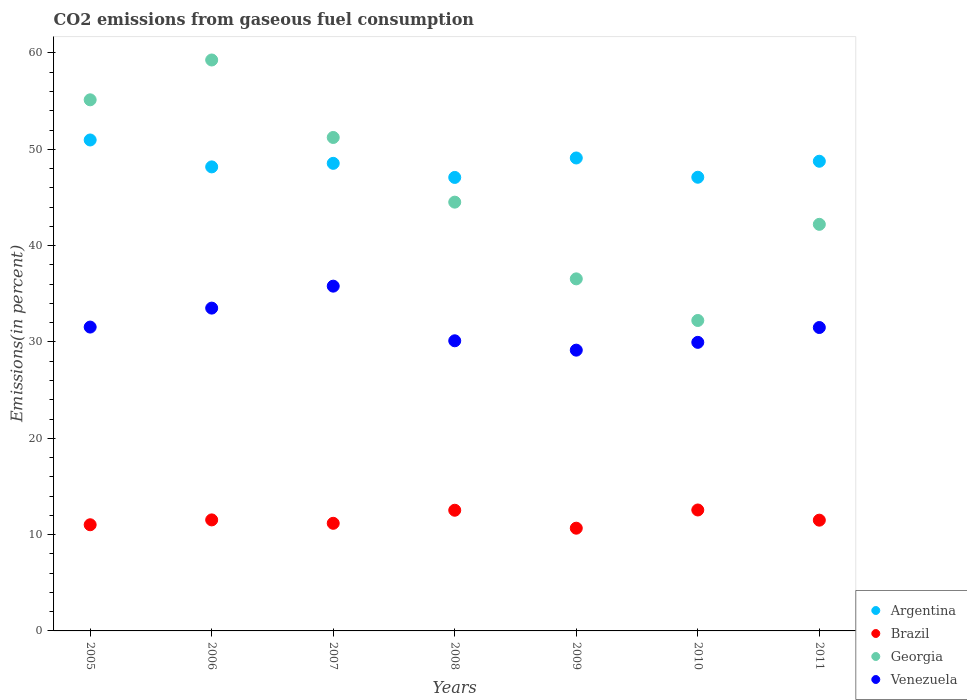What is the total CO2 emitted in Venezuela in 2011?
Your answer should be compact. 31.5. Across all years, what is the maximum total CO2 emitted in Venezuela?
Your answer should be compact. 35.79. Across all years, what is the minimum total CO2 emitted in Georgia?
Offer a terse response. 32.23. In which year was the total CO2 emitted in Argentina maximum?
Ensure brevity in your answer.  2005. What is the total total CO2 emitted in Venezuela in the graph?
Your answer should be compact. 221.58. What is the difference between the total CO2 emitted in Argentina in 2008 and that in 2010?
Your answer should be very brief. -0.02. What is the difference between the total CO2 emitted in Venezuela in 2011 and the total CO2 emitted in Argentina in 2007?
Provide a succinct answer. -17.04. What is the average total CO2 emitted in Georgia per year?
Offer a terse response. 45.88. In the year 2010, what is the difference between the total CO2 emitted in Argentina and total CO2 emitted in Venezuela?
Give a very brief answer. 17.14. What is the ratio of the total CO2 emitted in Venezuela in 2007 to that in 2009?
Your answer should be compact. 1.23. What is the difference between the highest and the second highest total CO2 emitted in Georgia?
Provide a succinct answer. 4.14. What is the difference between the highest and the lowest total CO2 emitted in Venezuela?
Your response must be concise. 6.64. Is the sum of the total CO2 emitted in Argentina in 2005 and 2008 greater than the maximum total CO2 emitted in Venezuela across all years?
Give a very brief answer. Yes. Is it the case that in every year, the sum of the total CO2 emitted in Venezuela and total CO2 emitted in Argentina  is greater than the sum of total CO2 emitted in Georgia and total CO2 emitted in Brazil?
Your answer should be compact. Yes. Is it the case that in every year, the sum of the total CO2 emitted in Georgia and total CO2 emitted in Argentina  is greater than the total CO2 emitted in Venezuela?
Give a very brief answer. Yes. Is the total CO2 emitted in Argentina strictly greater than the total CO2 emitted in Georgia over the years?
Keep it short and to the point. No. Is the total CO2 emitted in Venezuela strictly less than the total CO2 emitted in Brazil over the years?
Make the answer very short. No. How many dotlines are there?
Your answer should be very brief. 4. How many years are there in the graph?
Your answer should be compact. 7. Are the values on the major ticks of Y-axis written in scientific E-notation?
Offer a terse response. No. Where does the legend appear in the graph?
Provide a succinct answer. Bottom right. How many legend labels are there?
Your answer should be compact. 4. What is the title of the graph?
Offer a very short reply. CO2 emissions from gaseous fuel consumption. What is the label or title of the Y-axis?
Ensure brevity in your answer.  Emissions(in percent). What is the Emissions(in percent) of Argentina in 2005?
Give a very brief answer. 50.97. What is the Emissions(in percent) in Brazil in 2005?
Provide a short and direct response. 11.02. What is the Emissions(in percent) in Georgia in 2005?
Keep it short and to the point. 55.14. What is the Emissions(in percent) in Venezuela in 2005?
Your answer should be very brief. 31.54. What is the Emissions(in percent) in Argentina in 2006?
Offer a terse response. 48.17. What is the Emissions(in percent) of Brazil in 2006?
Offer a very short reply. 11.53. What is the Emissions(in percent) in Georgia in 2006?
Your answer should be very brief. 59.27. What is the Emissions(in percent) of Venezuela in 2006?
Offer a terse response. 33.51. What is the Emissions(in percent) of Argentina in 2007?
Make the answer very short. 48.54. What is the Emissions(in percent) in Brazil in 2007?
Provide a succinct answer. 11.17. What is the Emissions(in percent) of Georgia in 2007?
Your answer should be very brief. 51.23. What is the Emissions(in percent) of Venezuela in 2007?
Offer a terse response. 35.79. What is the Emissions(in percent) of Argentina in 2008?
Give a very brief answer. 47.08. What is the Emissions(in percent) in Brazil in 2008?
Your answer should be compact. 12.53. What is the Emissions(in percent) in Georgia in 2008?
Make the answer very short. 44.51. What is the Emissions(in percent) of Venezuela in 2008?
Your response must be concise. 30.12. What is the Emissions(in percent) in Argentina in 2009?
Your answer should be very brief. 49.1. What is the Emissions(in percent) in Brazil in 2009?
Your answer should be very brief. 10.66. What is the Emissions(in percent) of Georgia in 2009?
Give a very brief answer. 36.55. What is the Emissions(in percent) of Venezuela in 2009?
Your answer should be very brief. 29.15. What is the Emissions(in percent) in Argentina in 2010?
Make the answer very short. 47.1. What is the Emissions(in percent) in Brazil in 2010?
Provide a succinct answer. 12.56. What is the Emissions(in percent) of Georgia in 2010?
Offer a terse response. 32.23. What is the Emissions(in percent) of Venezuela in 2010?
Make the answer very short. 29.96. What is the Emissions(in percent) of Argentina in 2011?
Offer a terse response. 48.76. What is the Emissions(in percent) of Brazil in 2011?
Your answer should be very brief. 11.5. What is the Emissions(in percent) of Georgia in 2011?
Your response must be concise. 42.21. What is the Emissions(in percent) in Venezuela in 2011?
Ensure brevity in your answer.  31.5. Across all years, what is the maximum Emissions(in percent) of Argentina?
Your answer should be compact. 50.97. Across all years, what is the maximum Emissions(in percent) of Brazil?
Your answer should be very brief. 12.56. Across all years, what is the maximum Emissions(in percent) in Georgia?
Your answer should be very brief. 59.27. Across all years, what is the maximum Emissions(in percent) in Venezuela?
Your answer should be very brief. 35.79. Across all years, what is the minimum Emissions(in percent) of Argentina?
Your answer should be very brief. 47.08. Across all years, what is the minimum Emissions(in percent) in Brazil?
Provide a short and direct response. 10.66. Across all years, what is the minimum Emissions(in percent) of Georgia?
Make the answer very short. 32.23. Across all years, what is the minimum Emissions(in percent) of Venezuela?
Your answer should be compact. 29.15. What is the total Emissions(in percent) of Argentina in the graph?
Your response must be concise. 339.72. What is the total Emissions(in percent) in Brazil in the graph?
Your answer should be compact. 80.97. What is the total Emissions(in percent) of Georgia in the graph?
Offer a very short reply. 321.14. What is the total Emissions(in percent) in Venezuela in the graph?
Your answer should be very brief. 221.58. What is the difference between the Emissions(in percent) of Argentina in 2005 and that in 2006?
Give a very brief answer. 2.79. What is the difference between the Emissions(in percent) in Brazil in 2005 and that in 2006?
Give a very brief answer. -0.5. What is the difference between the Emissions(in percent) in Georgia in 2005 and that in 2006?
Provide a short and direct response. -4.13. What is the difference between the Emissions(in percent) in Venezuela in 2005 and that in 2006?
Your answer should be very brief. -1.97. What is the difference between the Emissions(in percent) of Argentina in 2005 and that in 2007?
Make the answer very short. 2.43. What is the difference between the Emissions(in percent) of Brazil in 2005 and that in 2007?
Your response must be concise. -0.15. What is the difference between the Emissions(in percent) in Georgia in 2005 and that in 2007?
Provide a short and direct response. 3.91. What is the difference between the Emissions(in percent) in Venezuela in 2005 and that in 2007?
Keep it short and to the point. -4.25. What is the difference between the Emissions(in percent) in Argentina in 2005 and that in 2008?
Your response must be concise. 3.89. What is the difference between the Emissions(in percent) in Brazil in 2005 and that in 2008?
Your response must be concise. -1.51. What is the difference between the Emissions(in percent) in Georgia in 2005 and that in 2008?
Keep it short and to the point. 10.62. What is the difference between the Emissions(in percent) in Venezuela in 2005 and that in 2008?
Make the answer very short. 1.42. What is the difference between the Emissions(in percent) of Argentina in 2005 and that in 2009?
Keep it short and to the point. 1.87. What is the difference between the Emissions(in percent) of Brazil in 2005 and that in 2009?
Your answer should be very brief. 0.36. What is the difference between the Emissions(in percent) in Georgia in 2005 and that in 2009?
Your answer should be very brief. 18.59. What is the difference between the Emissions(in percent) of Venezuela in 2005 and that in 2009?
Provide a succinct answer. 2.4. What is the difference between the Emissions(in percent) of Argentina in 2005 and that in 2010?
Provide a succinct answer. 3.87. What is the difference between the Emissions(in percent) of Brazil in 2005 and that in 2010?
Offer a very short reply. -1.53. What is the difference between the Emissions(in percent) in Georgia in 2005 and that in 2010?
Provide a succinct answer. 22.91. What is the difference between the Emissions(in percent) of Venezuela in 2005 and that in 2010?
Give a very brief answer. 1.59. What is the difference between the Emissions(in percent) of Argentina in 2005 and that in 2011?
Keep it short and to the point. 2.21. What is the difference between the Emissions(in percent) in Brazil in 2005 and that in 2011?
Give a very brief answer. -0.48. What is the difference between the Emissions(in percent) in Georgia in 2005 and that in 2011?
Your answer should be very brief. 12.93. What is the difference between the Emissions(in percent) of Venezuela in 2005 and that in 2011?
Ensure brevity in your answer.  0.05. What is the difference between the Emissions(in percent) of Argentina in 2006 and that in 2007?
Provide a short and direct response. -0.37. What is the difference between the Emissions(in percent) in Brazil in 2006 and that in 2007?
Provide a short and direct response. 0.35. What is the difference between the Emissions(in percent) in Georgia in 2006 and that in 2007?
Keep it short and to the point. 8.04. What is the difference between the Emissions(in percent) of Venezuela in 2006 and that in 2007?
Your answer should be compact. -2.28. What is the difference between the Emissions(in percent) in Argentina in 2006 and that in 2008?
Provide a short and direct response. 1.1. What is the difference between the Emissions(in percent) of Brazil in 2006 and that in 2008?
Offer a very short reply. -1. What is the difference between the Emissions(in percent) of Georgia in 2006 and that in 2008?
Provide a succinct answer. 14.76. What is the difference between the Emissions(in percent) of Venezuela in 2006 and that in 2008?
Provide a succinct answer. 3.39. What is the difference between the Emissions(in percent) in Argentina in 2006 and that in 2009?
Keep it short and to the point. -0.93. What is the difference between the Emissions(in percent) in Brazil in 2006 and that in 2009?
Offer a terse response. 0.86. What is the difference between the Emissions(in percent) in Georgia in 2006 and that in 2009?
Provide a short and direct response. 22.72. What is the difference between the Emissions(in percent) of Venezuela in 2006 and that in 2009?
Keep it short and to the point. 4.36. What is the difference between the Emissions(in percent) in Argentina in 2006 and that in 2010?
Offer a terse response. 1.08. What is the difference between the Emissions(in percent) in Brazil in 2006 and that in 2010?
Make the answer very short. -1.03. What is the difference between the Emissions(in percent) in Georgia in 2006 and that in 2010?
Offer a terse response. 27.04. What is the difference between the Emissions(in percent) in Venezuela in 2006 and that in 2010?
Provide a short and direct response. 3.55. What is the difference between the Emissions(in percent) of Argentina in 2006 and that in 2011?
Keep it short and to the point. -0.59. What is the difference between the Emissions(in percent) of Brazil in 2006 and that in 2011?
Offer a terse response. 0.03. What is the difference between the Emissions(in percent) of Georgia in 2006 and that in 2011?
Your answer should be very brief. 17.06. What is the difference between the Emissions(in percent) in Venezuela in 2006 and that in 2011?
Your response must be concise. 2.01. What is the difference between the Emissions(in percent) in Argentina in 2007 and that in 2008?
Provide a short and direct response. 1.46. What is the difference between the Emissions(in percent) of Brazil in 2007 and that in 2008?
Ensure brevity in your answer.  -1.36. What is the difference between the Emissions(in percent) of Georgia in 2007 and that in 2008?
Provide a short and direct response. 6.71. What is the difference between the Emissions(in percent) of Venezuela in 2007 and that in 2008?
Provide a short and direct response. 5.67. What is the difference between the Emissions(in percent) of Argentina in 2007 and that in 2009?
Give a very brief answer. -0.56. What is the difference between the Emissions(in percent) of Brazil in 2007 and that in 2009?
Provide a succinct answer. 0.51. What is the difference between the Emissions(in percent) in Georgia in 2007 and that in 2009?
Make the answer very short. 14.68. What is the difference between the Emissions(in percent) of Venezuela in 2007 and that in 2009?
Ensure brevity in your answer.  6.64. What is the difference between the Emissions(in percent) in Argentina in 2007 and that in 2010?
Ensure brevity in your answer.  1.44. What is the difference between the Emissions(in percent) of Brazil in 2007 and that in 2010?
Offer a terse response. -1.38. What is the difference between the Emissions(in percent) of Georgia in 2007 and that in 2010?
Your answer should be compact. 19. What is the difference between the Emissions(in percent) of Venezuela in 2007 and that in 2010?
Provide a short and direct response. 5.83. What is the difference between the Emissions(in percent) in Argentina in 2007 and that in 2011?
Provide a succinct answer. -0.22. What is the difference between the Emissions(in percent) of Brazil in 2007 and that in 2011?
Offer a terse response. -0.33. What is the difference between the Emissions(in percent) of Georgia in 2007 and that in 2011?
Keep it short and to the point. 9.02. What is the difference between the Emissions(in percent) in Venezuela in 2007 and that in 2011?
Make the answer very short. 4.29. What is the difference between the Emissions(in percent) in Argentina in 2008 and that in 2009?
Provide a short and direct response. -2.02. What is the difference between the Emissions(in percent) in Brazil in 2008 and that in 2009?
Ensure brevity in your answer.  1.86. What is the difference between the Emissions(in percent) of Georgia in 2008 and that in 2009?
Give a very brief answer. 7.96. What is the difference between the Emissions(in percent) of Venezuela in 2008 and that in 2009?
Provide a short and direct response. 0.97. What is the difference between the Emissions(in percent) of Argentina in 2008 and that in 2010?
Your answer should be very brief. -0.02. What is the difference between the Emissions(in percent) of Brazil in 2008 and that in 2010?
Ensure brevity in your answer.  -0.03. What is the difference between the Emissions(in percent) in Georgia in 2008 and that in 2010?
Provide a succinct answer. 12.29. What is the difference between the Emissions(in percent) of Venezuela in 2008 and that in 2010?
Make the answer very short. 0.16. What is the difference between the Emissions(in percent) of Argentina in 2008 and that in 2011?
Make the answer very short. -1.68. What is the difference between the Emissions(in percent) in Brazil in 2008 and that in 2011?
Your answer should be compact. 1.03. What is the difference between the Emissions(in percent) of Georgia in 2008 and that in 2011?
Provide a succinct answer. 2.3. What is the difference between the Emissions(in percent) of Venezuela in 2008 and that in 2011?
Make the answer very short. -1.38. What is the difference between the Emissions(in percent) in Argentina in 2009 and that in 2010?
Your answer should be compact. 2. What is the difference between the Emissions(in percent) in Brazil in 2009 and that in 2010?
Keep it short and to the point. -1.89. What is the difference between the Emissions(in percent) of Georgia in 2009 and that in 2010?
Your response must be concise. 4.32. What is the difference between the Emissions(in percent) of Venezuela in 2009 and that in 2010?
Give a very brief answer. -0.81. What is the difference between the Emissions(in percent) of Argentina in 2009 and that in 2011?
Provide a succinct answer. 0.34. What is the difference between the Emissions(in percent) in Brazil in 2009 and that in 2011?
Give a very brief answer. -0.83. What is the difference between the Emissions(in percent) of Georgia in 2009 and that in 2011?
Make the answer very short. -5.66. What is the difference between the Emissions(in percent) in Venezuela in 2009 and that in 2011?
Offer a terse response. -2.35. What is the difference between the Emissions(in percent) in Argentina in 2010 and that in 2011?
Provide a succinct answer. -1.66. What is the difference between the Emissions(in percent) of Brazil in 2010 and that in 2011?
Offer a very short reply. 1.06. What is the difference between the Emissions(in percent) of Georgia in 2010 and that in 2011?
Offer a very short reply. -9.98. What is the difference between the Emissions(in percent) in Venezuela in 2010 and that in 2011?
Make the answer very short. -1.54. What is the difference between the Emissions(in percent) of Argentina in 2005 and the Emissions(in percent) of Brazil in 2006?
Provide a succinct answer. 39.44. What is the difference between the Emissions(in percent) in Argentina in 2005 and the Emissions(in percent) in Georgia in 2006?
Your response must be concise. -8.3. What is the difference between the Emissions(in percent) of Argentina in 2005 and the Emissions(in percent) of Venezuela in 2006?
Offer a terse response. 17.46. What is the difference between the Emissions(in percent) in Brazil in 2005 and the Emissions(in percent) in Georgia in 2006?
Provide a short and direct response. -48.25. What is the difference between the Emissions(in percent) of Brazil in 2005 and the Emissions(in percent) of Venezuela in 2006?
Your answer should be compact. -22.49. What is the difference between the Emissions(in percent) of Georgia in 2005 and the Emissions(in percent) of Venezuela in 2006?
Offer a very short reply. 21.62. What is the difference between the Emissions(in percent) in Argentina in 2005 and the Emissions(in percent) in Brazil in 2007?
Offer a terse response. 39.8. What is the difference between the Emissions(in percent) of Argentina in 2005 and the Emissions(in percent) of Georgia in 2007?
Provide a succinct answer. -0.26. What is the difference between the Emissions(in percent) in Argentina in 2005 and the Emissions(in percent) in Venezuela in 2007?
Provide a succinct answer. 15.18. What is the difference between the Emissions(in percent) of Brazil in 2005 and the Emissions(in percent) of Georgia in 2007?
Give a very brief answer. -40.21. What is the difference between the Emissions(in percent) in Brazil in 2005 and the Emissions(in percent) in Venezuela in 2007?
Make the answer very short. -24.77. What is the difference between the Emissions(in percent) of Georgia in 2005 and the Emissions(in percent) of Venezuela in 2007?
Provide a short and direct response. 19.34. What is the difference between the Emissions(in percent) of Argentina in 2005 and the Emissions(in percent) of Brazil in 2008?
Offer a very short reply. 38.44. What is the difference between the Emissions(in percent) of Argentina in 2005 and the Emissions(in percent) of Georgia in 2008?
Give a very brief answer. 6.45. What is the difference between the Emissions(in percent) in Argentina in 2005 and the Emissions(in percent) in Venezuela in 2008?
Your response must be concise. 20.85. What is the difference between the Emissions(in percent) in Brazil in 2005 and the Emissions(in percent) in Georgia in 2008?
Provide a succinct answer. -33.49. What is the difference between the Emissions(in percent) in Brazil in 2005 and the Emissions(in percent) in Venezuela in 2008?
Provide a succinct answer. -19.1. What is the difference between the Emissions(in percent) in Georgia in 2005 and the Emissions(in percent) in Venezuela in 2008?
Give a very brief answer. 25.02. What is the difference between the Emissions(in percent) of Argentina in 2005 and the Emissions(in percent) of Brazil in 2009?
Keep it short and to the point. 40.3. What is the difference between the Emissions(in percent) of Argentina in 2005 and the Emissions(in percent) of Georgia in 2009?
Keep it short and to the point. 14.42. What is the difference between the Emissions(in percent) in Argentina in 2005 and the Emissions(in percent) in Venezuela in 2009?
Provide a succinct answer. 21.82. What is the difference between the Emissions(in percent) of Brazil in 2005 and the Emissions(in percent) of Georgia in 2009?
Offer a terse response. -25.53. What is the difference between the Emissions(in percent) in Brazil in 2005 and the Emissions(in percent) in Venezuela in 2009?
Your answer should be very brief. -18.13. What is the difference between the Emissions(in percent) in Georgia in 2005 and the Emissions(in percent) in Venezuela in 2009?
Your answer should be compact. 25.99. What is the difference between the Emissions(in percent) of Argentina in 2005 and the Emissions(in percent) of Brazil in 2010?
Your answer should be very brief. 38.41. What is the difference between the Emissions(in percent) in Argentina in 2005 and the Emissions(in percent) in Georgia in 2010?
Your answer should be compact. 18.74. What is the difference between the Emissions(in percent) of Argentina in 2005 and the Emissions(in percent) of Venezuela in 2010?
Your answer should be compact. 21.01. What is the difference between the Emissions(in percent) of Brazil in 2005 and the Emissions(in percent) of Georgia in 2010?
Your answer should be very brief. -21.21. What is the difference between the Emissions(in percent) of Brazil in 2005 and the Emissions(in percent) of Venezuela in 2010?
Provide a short and direct response. -18.94. What is the difference between the Emissions(in percent) in Georgia in 2005 and the Emissions(in percent) in Venezuela in 2010?
Your answer should be compact. 25.18. What is the difference between the Emissions(in percent) of Argentina in 2005 and the Emissions(in percent) of Brazil in 2011?
Make the answer very short. 39.47. What is the difference between the Emissions(in percent) in Argentina in 2005 and the Emissions(in percent) in Georgia in 2011?
Provide a short and direct response. 8.76. What is the difference between the Emissions(in percent) of Argentina in 2005 and the Emissions(in percent) of Venezuela in 2011?
Ensure brevity in your answer.  19.47. What is the difference between the Emissions(in percent) of Brazil in 2005 and the Emissions(in percent) of Georgia in 2011?
Your answer should be very brief. -31.19. What is the difference between the Emissions(in percent) in Brazil in 2005 and the Emissions(in percent) in Venezuela in 2011?
Your answer should be compact. -20.48. What is the difference between the Emissions(in percent) in Georgia in 2005 and the Emissions(in percent) in Venezuela in 2011?
Offer a terse response. 23.64. What is the difference between the Emissions(in percent) of Argentina in 2006 and the Emissions(in percent) of Brazil in 2007?
Ensure brevity in your answer.  37. What is the difference between the Emissions(in percent) in Argentina in 2006 and the Emissions(in percent) in Georgia in 2007?
Make the answer very short. -3.05. What is the difference between the Emissions(in percent) in Argentina in 2006 and the Emissions(in percent) in Venezuela in 2007?
Offer a very short reply. 12.38. What is the difference between the Emissions(in percent) of Brazil in 2006 and the Emissions(in percent) of Georgia in 2007?
Provide a short and direct response. -39.7. What is the difference between the Emissions(in percent) of Brazil in 2006 and the Emissions(in percent) of Venezuela in 2007?
Your answer should be compact. -24.27. What is the difference between the Emissions(in percent) in Georgia in 2006 and the Emissions(in percent) in Venezuela in 2007?
Your answer should be very brief. 23.48. What is the difference between the Emissions(in percent) of Argentina in 2006 and the Emissions(in percent) of Brazil in 2008?
Your answer should be compact. 35.65. What is the difference between the Emissions(in percent) of Argentina in 2006 and the Emissions(in percent) of Georgia in 2008?
Make the answer very short. 3.66. What is the difference between the Emissions(in percent) in Argentina in 2006 and the Emissions(in percent) in Venezuela in 2008?
Offer a terse response. 18.05. What is the difference between the Emissions(in percent) of Brazil in 2006 and the Emissions(in percent) of Georgia in 2008?
Ensure brevity in your answer.  -32.99. What is the difference between the Emissions(in percent) of Brazil in 2006 and the Emissions(in percent) of Venezuela in 2008?
Give a very brief answer. -18.59. What is the difference between the Emissions(in percent) of Georgia in 2006 and the Emissions(in percent) of Venezuela in 2008?
Keep it short and to the point. 29.15. What is the difference between the Emissions(in percent) of Argentina in 2006 and the Emissions(in percent) of Brazil in 2009?
Your answer should be very brief. 37.51. What is the difference between the Emissions(in percent) in Argentina in 2006 and the Emissions(in percent) in Georgia in 2009?
Your answer should be very brief. 11.62. What is the difference between the Emissions(in percent) in Argentina in 2006 and the Emissions(in percent) in Venezuela in 2009?
Your answer should be compact. 19.03. What is the difference between the Emissions(in percent) in Brazil in 2006 and the Emissions(in percent) in Georgia in 2009?
Your answer should be very brief. -25.02. What is the difference between the Emissions(in percent) in Brazil in 2006 and the Emissions(in percent) in Venezuela in 2009?
Your answer should be very brief. -17.62. What is the difference between the Emissions(in percent) in Georgia in 2006 and the Emissions(in percent) in Venezuela in 2009?
Make the answer very short. 30.12. What is the difference between the Emissions(in percent) in Argentina in 2006 and the Emissions(in percent) in Brazil in 2010?
Provide a succinct answer. 35.62. What is the difference between the Emissions(in percent) of Argentina in 2006 and the Emissions(in percent) of Georgia in 2010?
Give a very brief answer. 15.95. What is the difference between the Emissions(in percent) of Argentina in 2006 and the Emissions(in percent) of Venezuela in 2010?
Your answer should be very brief. 18.22. What is the difference between the Emissions(in percent) in Brazil in 2006 and the Emissions(in percent) in Georgia in 2010?
Your answer should be compact. -20.7. What is the difference between the Emissions(in percent) of Brazil in 2006 and the Emissions(in percent) of Venezuela in 2010?
Provide a short and direct response. -18.43. What is the difference between the Emissions(in percent) in Georgia in 2006 and the Emissions(in percent) in Venezuela in 2010?
Provide a short and direct response. 29.31. What is the difference between the Emissions(in percent) in Argentina in 2006 and the Emissions(in percent) in Brazil in 2011?
Ensure brevity in your answer.  36.68. What is the difference between the Emissions(in percent) of Argentina in 2006 and the Emissions(in percent) of Georgia in 2011?
Your response must be concise. 5.96. What is the difference between the Emissions(in percent) of Argentina in 2006 and the Emissions(in percent) of Venezuela in 2011?
Your response must be concise. 16.68. What is the difference between the Emissions(in percent) in Brazil in 2006 and the Emissions(in percent) in Georgia in 2011?
Make the answer very short. -30.68. What is the difference between the Emissions(in percent) in Brazil in 2006 and the Emissions(in percent) in Venezuela in 2011?
Make the answer very short. -19.97. What is the difference between the Emissions(in percent) in Georgia in 2006 and the Emissions(in percent) in Venezuela in 2011?
Your answer should be compact. 27.77. What is the difference between the Emissions(in percent) in Argentina in 2007 and the Emissions(in percent) in Brazil in 2008?
Provide a succinct answer. 36.01. What is the difference between the Emissions(in percent) in Argentina in 2007 and the Emissions(in percent) in Georgia in 2008?
Provide a short and direct response. 4.03. What is the difference between the Emissions(in percent) in Argentina in 2007 and the Emissions(in percent) in Venezuela in 2008?
Your response must be concise. 18.42. What is the difference between the Emissions(in percent) of Brazil in 2007 and the Emissions(in percent) of Georgia in 2008?
Your response must be concise. -33.34. What is the difference between the Emissions(in percent) of Brazil in 2007 and the Emissions(in percent) of Venezuela in 2008?
Provide a succinct answer. -18.95. What is the difference between the Emissions(in percent) in Georgia in 2007 and the Emissions(in percent) in Venezuela in 2008?
Keep it short and to the point. 21.11. What is the difference between the Emissions(in percent) in Argentina in 2007 and the Emissions(in percent) in Brazil in 2009?
Offer a terse response. 37.88. What is the difference between the Emissions(in percent) in Argentina in 2007 and the Emissions(in percent) in Georgia in 2009?
Offer a very short reply. 11.99. What is the difference between the Emissions(in percent) in Argentina in 2007 and the Emissions(in percent) in Venezuela in 2009?
Give a very brief answer. 19.39. What is the difference between the Emissions(in percent) of Brazil in 2007 and the Emissions(in percent) of Georgia in 2009?
Offer a terse response. -25.38. What is the difference between the Emissions(in percent) of Brazil in 2007 and the Emissions(in percent) of Venezuela in 2009?
Keep it short and to the point. -17.98. What is the difference between the Emissions(in percent) in Georgia in 2007 and the Emissions(in percent) in Venezuela in 2009?
Provide a short and direct response. 22.08. What is the difference between the Emissions(in percent) of Argentina in 2007 and the Emissions(in percent) of Brazil in 2010?
Your answer should be very brief. 35.99. What is the difference between the Emissions(in percent) of Argentina in 2007 and the Emissions(in percent) of Georgia in 2010?
Offer a terse response. 16.31. What is the difference between the Emissions(in percent) in Argentina in 2007 and the Emissions(in percent) in Venezuela in 2010?
Keep it short and to the point. 18.58. What is the difference between the Emissions(in percent) in Brazil in 2007 and the Emissions(in percent) in Georgia in 2010?
Ensure brevity in your answer.  -21.06. What is the difference between the Emissions(in percent) of Brazil in 2007 and the Emissions(in percent) of Venezuela in 2010?
Ensure brevity in your answer.  -18.79. What is the difference between the Emissions(in percent) of Georgia in 2007 and the Emissions(in percent) of Venezuela in 2010?
Your response must be concise. 21.27. What is the difference between the Emissions(in percent) in Argentina in 2007 and the Emissions(in percent) in Brazil in 2011?
Make the answer very short. 37.04. What is the difference between the Emissions(in percent) of Argentina in 2007 and the Emissions(in percent) of Georgia in 2011?
Make the answer very short. 6.33. What is the difference between the Emissions(in percent) of Argentina in 2007 and the Emissions(in percent) of Venezuela in 2011?
Provide a short and direct response. 17.04. What is the difference between the Emissions(in percent) in Brazil in 2007 and the Emissions(in percent) in Georgia in 2011?
Your answer should be compact. -31.04. What is the difference between the Emissions(in percent) of Brazil in 2007 and the Emissions(in percent) of Venezuela in 2011?
Keep it short and to the point. -20.33. What is the difference between the Emissions(in percent) in Georgia in 2007 and the Emissions(in percent) in Venezuela in 2011?
Offer a very short reply. 19.73. What is the difference between the Emissions(in percent) of Argentina in 2008 and the Emissions(in percent) of Brazil in 2009?
Your response must be concise. 36.41. What is the difference between the Emissions(in percent) of Argentina in 2008 and the Emissions(in percent) of Georgia in 2009?
Your answer should be compact. 10.53. What is the difference between the Emissions(in percent) of Argentina in 2008 and the Emissions(in percent) of Venezuela in 2009?
Your answer should be very brief. 17.93. What is the difference between the Emissions(in percent) in Brazil in 2008 and the Emissions(in percent) in Georgia in 2009?
Offer a very short reply. -24.02. What is the difference between the Emissions(in percent) of Brazil in 2008 and the Emissions(in percent) of Venezuela in 2009?
Provide a short and direct response. -16.62. What is the difference between the Emissions(in percent) in Georgia in 2008 and the Emissions(in percent) in Venezuela in 2009?
Your response must be concise. 15.37. What is the difference between the Emissions(in percent) of Argentina in 2008 and the Emissions(in percent) of Brazil in 2010?
Your response must be concise. 34.52. What is the difference between the Emissions(in percent) of Argentina in 2008 and the Emissions(in percent) of Georgia in 2010?
Give a very brief answer. 14.85. What is the difference between the Emissions(in percent) in Argentina in 2008 and the Emissions(in percent) in Venezuela in 2010?
Offer a terse response. 17.12. What is the difference between the Emissions(in percent) of Brazil in 2008 and the Emissions(in percent) of Georgia in 2010?
Offer a terse response. -19.7. What is the difference between the Emissions(in percent) of Brazil in 2008 and the Emissions(in percent) of Venezuela in 2010?
Your answer should be compact. -17.43. What is the difference between the Emissions(in percent) in Georgia in 2008 and the Emissions(in percent) in Venezuela in 2010?
Provide a succinct answer. 14.56. What is the difference between the Emissions(in percent) of Argentina in 2008 and the Emissions(in percent) of Brazil in 2011?
Your response must be concise. 35.58. What is the difference between the Emissions(in percent) in Argentina in 2008 and the Emissions(in percent) in Georgia in 2011?
Offer a very short reply. 4.87. What is the difference between the Emissions(in percent) of Argentina in 2008 and the Emissions(in percent) of Venezuela in 2011?
Ensure brevity in your answer.  15.58. What is the difference between the Emissions(in percent) of Brazil in 2008 and the Emissions(in percent) of Georgia in 2011?
Provide a short and direct response. -29.68. What is the difference between the Emissions(in percent) in Brazil in 2008 and the Emissions(in percent) in Venezuela in 2011?
Give a very brief answer. -18.97. What is the difference between the Emissions(in percent) of Georgia in 2008 and the Emissions(in percent) of Venezuela in 2011?
Your response must be concise. 13.02. What is the difference between the Emissions(in percent) of Argentina in 2009 and the Emissions(in percent) of Brazil in 2010?
Make the answer very short. 36.54. What is the difference between the Emissions(in percent) in Argentina in 2009 and the Emissions(in percent) in Georgia in 2010?
Keep it short and to the point. 16.87. What is the difference between the Emissions(in percent) of Argentina in 2009 and the Emissions(in percent) of Venezuela in 2010?
Provide a succinct answer. 19.14. What is the difference between the Emissions(in percent) of Brazil in 2009 and the Emissions(in percent) of Georgia in 2010?
Your answer should be compact. -21.56. What is the difference between the Emissions(in percent) in Brazil in 2009 and the Emissions(in percent) in Venezuela in 2010?
Ensure brevity in your answer.  -19.29. What is the difference between the Emissions(in percent) of Georgia in 2009 and the Emissions(in percent) of Venezuela in 2010?
Give a very brief answer. 6.59. What is the difference between the Emissions(in percent) of Argentina in 2009 and the Emissions(in percent) of Brazil in 2011?
Provide a succinct answer. 37.6. What is the difference between the Emissions(in percent) of Argentina in 2009 and the Emissions(in percent) of Georgia in 2011?
Ensure brevity in your answer.  6.89. What is the difference between the Emissions(in percent) of Argentina in 2009 and the Emissions(in percent) of Venezuela in 2011?
Your answer should be very brief. 17.6. What is the difference between the Emissions(in percent) in Brazil in 2009 and the Emissions(in percent) in Georgia in 2011?
Provide a short and direct response. -31.54. What is the difference between the Emissions(in percent) in Brazil in 2009 and the Emissions(in percent) in Venezuela in 2011?
Your answer should be very brief. -20.83. What is the difference between the Emissions(in percent) in Georgia in 2009 and the Emissions(in percent) in Venezuela in 2011?
Offer a very short reply. 5.05. What is the difference between the Emissions(in percent) in Argentina in 2010 and the Emissions(in percent) in Brazil in 2011?
Ensure brevity in your answer.  35.6. What is the difference between the Emissions(in percent) in Argentina in 2010 and the Emissions(in percent) in Georgia in 2011?
Make the answer very short. 4.89. What is the difference between the Emissions(in percent) of Argentina in 2010 and the Emissions(in percent) of Venezuela in 2011?
Give a very brief answer. 15.6. What is the difference between the Emissions(in percent) of Brazil in 2010 and the Emissions(in percent) of Georgia in 2011?
Your answer should be compact. -29.65. What is the difference between the Emissions(in percent) in Brazil in 2010 and the Emissions(in percent) in Venezuela in 2011?
Provide a succinct answer. -18.94. What is the difference between the Emissions(in percent) in Georgia in 2010 and the Emissions(in percent) in Venezuela in 2011?
Your answer should be compact. 0.73. What is the average Emissions(in percent) of Argentina per year?
Offer a terse response. 48.53. What is the average Emissions(in percent) of Brazil per year?
Keep it short and to the point. 11.57. What is the average Emissions(in percent) of Georgia per year?
Ensure brevity in your answer.  45.88. What is the average Emissions(in percent) in Venezuela per year?
Ensure brevity in your answer.  31.65. In the year 2005, what is the difference between the Emissions(in percent) in Argentina and Emissions(in percent) in Brazil?
Your response must be concise. 39.95. In the year 2005, what is the difference between the Emissions(in percent) in Argentina and Emissions(in percent) in Georgia?
Provide a short and direct response. -4.17. In the year 2005, what is the difference between the Emissions(in percent) in Argentina and Emissions(in percent) in Venezuela?
Offer a very short reply. 19.42. In the year 2005, what is the difference between the Emissions(in percent) in Brazil and Emissions(in percent) in Georgia?
Offer a very short reply. -44.12. In the year 2005, what is the difference between the Emissions(in percent) in Brazil and Emissions(in percent) in Venezuela?
Your answer should be very brief. -20.52. In the year 2005, what is the difference between the Emissions(in percent) of Georgia and Emissions(in percent) of Venezuela?
Offer a very short reply. 23.59. In the year 2006, what is the difference between the Emissions(in percent) of Argentina and Emissions(in percent) of Brazil?
Provide a succinct answer. 36.65. In the year 2006, what is the difference between the Emissions(in percent) of Argentina and Emissions(in percent) of Georgia?
Keep it short and to the point. -11.1. In the year 2006, what is the difference between the Emissions(in percent) of Argentina and Emissions(in percent) of Venezuela?
Offer a terse response. 14.66. In the year 2006, what is the difference between the Emissions(in percent) of Brazil and Emissions(in percent) of Georgia?
Give a very brief answer. -47.75. In the year 2006, what is the difference between the Emissions(in percent) in Brazil and Emissions(in percent) in Venezuela?
Make the answer very short. -21.99. In the year 2006, what is the difference between the Emissions(in percent) of Georgia and Emissions(in percent) of Venezuela?
Provide a succinct answer. 25.76. In the year 2007, what is the difference between the Emissions(in percent) in Argentina and Emissions(in percent) in Brazil?
Provide a short and direct response. 37.37. In the year 2007, what is the difference between the Emissions(in percent) of Argentina and Emissions(in percent) of Georgia?
Keep it short and to the point. -2.69. In the year 2007, what is the difference between the Emissions(in percent) in Argentina and Emissions(in percent) in Venezuela?
Provide a short and direct response. 12.75. In the year 2007, what is the difference between the Emissions(in percent) of Brazil and Emissions(in percent) of Georgia?
Your response must be concise. -40.06. In the year 2007, what is the difference between the Emissions(in percent) in Brazil and Emissions(in percent) in Venezuela?
Offer a terse response. -24.62. In the year 2007, what is the difference between the Emissions(in percent) in Georgia and Emissions(in percent) in Venezuela?
Provide a succinct answer. 15.44. In the year 2008, what is the difference between the Emissions(in percent) in Argentina and Emissions(in percent) in Brazil?
Provide a short and direct response. 34.55. In the year 2008, what is the difference between the Emissions(in percent) in Argentina and Emissions(in percent) in Georgia?
Give a very brief answer. 2.56. In the year 2008, what is the difference between the Emissions(in percent) of Argentina and Emissions(in percent) of Venezuela?
Your answer should be compact. 16.96. In the year 2008, what is the difference between the Emissions(in percent) in Brazil and Emissions(in percent) in Georgia?
Ensure brevity in your answer.  -31.99. In the year 2008, what is the difference between the Emissions(in percent) of Brazil and Emissions(in percent) of Venezuela?
Your answer should be very brief. -17.59. In the year 2008, what is the difference between the Emissions(in percent) of Georgia and Emissions(in percent) of Venezuela?
Offer a very short reply. 14.39. In the year 2009, what is the difference between the Emissions(in percent) of Argentina and Emissions(in percent) of Brazil?
Keep it short and to the point. 38.43. In the year 2009, what is the difference between the Emissions(in percent) of Argentina and Emissions(in percent) of Georgia?
Your answer should be compact. 12.55. In the year 2009, what is the difference between the Emissions(in percent) in Argentina and Emissions(in percent) in Venezuela?
Your response must be concise. 19.95. In the year 2009, what is the difference between the Emissions(in percent) in Brazil and Emissions(in percent) in Georgia?
Your answer should be compact. -25.88. In the year 2009, what is the difference between the Emissions(in percent) in Brazil and Emissions(in percent) in Venezuela?
Offer a very short reply. -18.48. In the year 2009, what is the difference between the Emissions(in percent) of Georgia and Emissions(in percent) of Venezuela?
Your response must be concise. 7.4. In the year 2010, what is the difference between the Emissions(in percent) in Argentina and Emissions(in percent) in Brazil?
Provide a short and direct response. 34.54. In the year 2010, what is the difference between the Emissions(in percent) of Argentina and Emissions(in percent) of Georgia?
Provide a short and direct response. 14.87. In the year 2010, what is the difference between the Emissions(in percent) of Argentina and Emissions(in percent) of Venezuela?
Ensure brevity in your answer.  17.14. In the year 2010, what is the difference between the Emissions(in percent) in Brazil and Emissions(in percent) in Georgia?
Offer a terse response. -19.67. In the year 2010, what is the difference between the Emissions(in percent) of Brazil and Emissions(in percent) of Venezuela?
Give a very brief answer. -17.4. In the year 2010, what is the difference between the Emissions(in percent) in Georgia and Emissions(in percent) in Venezuela?
Offer a very short reply. 2.27. In the year 2011, what is the difference between the Emissions(in percent) of Argentina and Emissions(in percent) of Brazil?
Offer a terse response. 37.26. In the year 2011, what is the difference between the Emissions(in percent) of Argentina and Emissions(in percent) of Georgia?
Provide a short and direct response. 6.55. In the year 2011, what is the difference between the Emissions(in percent) in Argentina and Emissions(in percent) in Venezuela?
Your response must be concise. 17.26. In the year 2011, what is the difference between the Emissions(in percent) of Brazil and Emissions(in percent) of Georgia?
Your answer should be compact. -30.71. In the year 2011, what is the difference between the Emissions(in percent) of Brazil and Emissions(in percent) of Venezuela?
Give a very brief answer. -20. In the year 2011, what is the difference between the Emissions(in percent) in Georgia and Emissions(in percent) in Venezuela?
Offer a very short reply. 10.71. What is the ratio of the Emissions(in percent) of Argentina in 2005 to that in 2006?
Offer a terse response. 1.06. What is the ratio of the Emissions(in percent) in Brazil in 2005 to that in 2006?
Ensure brevity in your answer.  0.96. What is the ratio of the Emissions(in percent) in Georgia in 2005 to that in 2006?
Your response must be concise. 0.93. What is the ratio of the Emissions(in percent) in Venezuela in 2005 to that in 2006?
Your answer should be compact. 0.94. What is the ratio of the Emissions(in percent) of Argentina in 2005 to that in 2007?
Provide a short and direct response. 1.05. What is the ratio of the Emissions(in percent) of Brazil in 2005 to that in 2007?
Offer a very short reply. 0.99. What is the ratio of the Emissions(in percent) in Georgia in 2005 to that in 2007?
Ensure brevity in your answer.  1.08. What is the ratio of the Emissions(in percent) of Venezuela in 2005 to that in 2007?
Keep it short and to the point. 0.88. What is the ratio of the Emissions(in percent) of Argentina in 2005 to that in 2008?
Make the answer very short. 1.08. What is the ratio of the Emissions(in percent) in Brazil in 2005 to that in 2008?
Keep it short and to the point. 0.88. What is the ratio of the Emissions(in percent) of Georgia in 2005 to that in 2008?
Offer a terse response. 1.24. What is the ratio of the Emissions(in percent) of Venezuela in 2005 to that in 2008?
Make the answer very short. 1.05. What is the ratio of the Emissions(in percent) in Argentina in 2005 to that in 2009?
Offer a terse response. 1.04. What is the ratio of the Emissions(in percent) in Brazil in 2005 to that in 2009?
Offer a terse response. 1.03. What is the ratio of the Emissions(in percent) of Georgia in 2005 to that in 2009?
Offer a very short reply. 1.51. What is the ratio of the Emissions(in percent) in Venezuela in 2005 to that in 2009?
Your response must be concise. 1.08. What is the ratio of the Emissions(in percent) of Argentina in 2005 to that in 2010?
Make the answer very short. 1.08. What is the ratio of the Emissions(in percent) of Brazil in 2005 to that in 2010?
Make the answer very short. 0.88. What is the ratio of the Emissions(in percent) in Georgia in 2005 to that in 2010?
Ensure brevity in your answer.  1.71. What is the ratio of the Emissions(in percent) in Venezuela in 2005 to that in 2010?
Make the answer very short. 1.05. What is the ratio of the Emissions(in percent) of Argentina in 2005 to that in 2011?
Offer a terse response. 1.05. What is the ratio of the Emissions(in percent) in Brazil in 2005 to that in 2011?
Provide a succinct answer. 0.96. What is the ratio of the Emissions(in percent) in Georgia in 2005 to that in 2011?
Your response must be concise. 1.31. What is the ratio of the Emissions(in percent) in Venezuela in 2005 to that in 2011?
Ensure brevity in your answer.  1. What is the ratio of the Emissions(in percent) in Brazil in 2006 to that in 2007?
Offer a terse response. 1.03. What is the ratio of the Emissions(in percent) of Georgia in 2006 to that in 2007?
Make the answer very short. 1.16. What is the ratio of the Emissions(in percent) in Venezuela in 2006 to that in 2007?
Keep it short and to the point. 0.94. What is the ratio of the Emissions(in percent) of Argentina in 2006 to that in 2008?
Make the answer very short. 1.02. What is the ratio of the Emissions(in percent) in Brazil in 2006 to that in 2008?
Provide a succinct answer. 0.92. What is the ratio of the Emissions(in percent) of Georgia in 2006 to that in 2008?
Your response must be concise. 1.33. What is the ratio of the Emissions(in percent) in Venezuela in 2006 to that in 2008?
Provide a succinct answer. 1.11. What is the ratio of the Emissions(in percent) of Argentina in 2006 to that in 2009?
Your answer should be compact. 0.98. What is the ratio of the Emissions(in percent) in Brazil in 2006 to that in 2009?
Keep it short and to the point. 1.08. What is the ratio of the Emissions(in percent) of Georgia in 2006 to that in 2009?
Offer a terse response. 1.62. What is the ratio of the Emissions(in percent) of Venezuela in 2006 to that in 2009?
Provide a short and direct response. 1.15. What is the ratio of the Emissions(in percent) in Argentina in 2006 to that in 2010?
Your answer should be very brief. 1.02. What is the ratio of the Emissions(in percent) of Brazil in 2006 to that in 2010?
Offer a terse response. 0.92. What is the ratio of the Emissions(in percent) of Georgia in 2006 to that in 2010?
Provide a succinct answer. 1.84. What is the ratio of the Emissions(in percent) of Venezuela in 2006 to that in 2010?
Provide a succinct answer. 1.12. What is the ratio of the Emissions(in percent) of Brazil in 2006 to that in 2011?
Offer a terse response. 1. What is the ratio of the Emissions(in percent) in Georgia in 2006 to that in 2011?
Ensure brevity in your answer.  1.4. What is the ratio of the Emissions(in percent) in Venezuela in 2006 to that in 2011?
Give a very brief answer. 1.06. What is the ratio of the Emissions(in percent) in Argentina in 2007 to that in 2008?
Provide a succinct answer. 1.03. What is the ratio of the Emissions(in percent) in Brazil in 2007 to that in 2008?
Ensure brevity in your answer.  0.89. What is the ratio of the Emissions(in percent) in Georgia in 2007 to that in 2008?
Provide a short and direct response. 1.15. What is the ratio of the Emissions(in percent) in Venezuela in 2007 to that in 2008?
Give a very brief answer. 1.19. What is the ratio of the Emissions(in percent) of Brazil in 2007 to that in 2009?
Your answer should be compact. 1.05. What is the ratio of the Emissions(in percent) of Georgia in 2007 to that in 2009?
Your answer should be very brief. 1.4. What is the ratio of the Emissions(in percent) in Venezuela in 2007 to that in 2009?
Your answer should be compact. 1.23. What is the ratio of the Emissions(in percent) in Argentina in 2007 to that in 2010?
Offer a very short reply. 1.03. What is the ratio of the Emissions(in percent) of Brazil in 2007 to that in 2010?
Provide a short and direct response. 0.89. What is the ratio of the Emissions(in percent) of Georgia in 2007 to that in 2010?
Offer a very short reply. 1.59. What is the ratio of the Emissions(in percent) in Venezuela in 2007 to that in 2010?
Provide a short and direct response. 1.19. What is the ratio of the Emissions(in percent) of Argentina in 2007 to that in 2011?
Keep it short and to the point. 1. What is the ratio of the Emissions(in percent) of Brazil in 2007 to that in 2011?
Ensure brevity in your answer.  0.97. What is the ratio of the Emissions(in percent) of Georgia in 2007 to that in 2011?
Offer a terse response. 1.21. What is the ratio of the Emissions(in percent) of Venezuela in 2007 to that in 2011?
Give a very brief answer. 1.14. What is the ratio of the Emissions(in percent) of Argentina in 2008 to that in 2009?
Offer a terse response. 0.96. What is the ratio of the Emissions(in percent) in Brazil in 2008 to that in 2009?
Offer a terse response. 1.17. What is the ratio of the Emissions(in percent) in Georgia in 2008 to that in 2009?
Give a very brief answer. 1.22. What is the ratio of the Emissions(in percent) in Brazil in 2008 to that in 2010?
Your answer should be compact. 1. What is the ratio of the Emissions(in percent) of Georgia in 2008 to that in 2010?
Your answer should be very brief. 1.38. What is the ratio of the Emissions(in percent) in Venezuela in 2008 to that in 2010?
Keep it short and to the point. 1.01. What is the ratio of the Emissions(in percent) of Argentina in 2008 to that in 2011?
Your answer should be compact. 0.97. What is the ratio of the Emissions(in percent) of Brazil in 2008 to that in 2011?
Ensure brevity in your answer.  1.09. What is the ratio of the Emissions(in percent) of Georgia in 2008 to that in 2011?
Your response must be concise. 1.05. What is the ratio of the Emissions(in percent) of Venezuela in 2008 to that in 2011?
Provide a short and direct response. 0.96. What is the ratio of the Emissions(in percent) of Argentina in 2009 to that in 2010?
Provide a succinct answer. 1.04. What is the ratio of the Emissions(in percent) in Brazil in 2009 to that in 2010?
Provide a short and direct response. 0.85. What is the ratio of the Emissions(in percent) of Georgia in 2009 to that in 2010?
Provide a succinct answer. 1.13. What is the ratio of the Emissions(in percent) of Venezuela in 2009 to that in 2010?
Make the answer very short. 0.97. What is the ratio of the Emissions(in percent) in Argentina in 2009 to that in 2011?
Offer a very short reply. 1.01. What is the ratio of the Emissions(in percent) in Brazil in 2009 to that in 2011?
Give a very brief answer. 0.93. What is the ratio of the Emissions(in percent) of Georgia in 2009 to that in 2011?
Your answer should be very brief. 0.87. What is the ratio of the Emissions(in percent) of Venezuela in 2009 to that in 2011?
Offer a terse response. 0.93. What is the ratio of the Emissions(in percent) in Argentina in 2010 to that in 2011?
Offer a very short reply. 0.97. What is the ratio of the Emissions(in percent) of Brazil in 2010 to that in 2011?
Your answer should be very brief. 1.09. What is the ratio of the Emissions(in percent) in Georgia in 2010 to that in 2011?
Ensure brevity in your answer.  0.76. What is the ratio of the Emissions(in percent) in Venezuela in 2010 to that in 2011?
Offer a very short reply. 0.95. What is the difference between the highest and the second highest Emissions(in percent) of Argentina?
Offer a terse response. 1.87. What is the difference between the highest and the second highest Emissions(in percent) in Brazil?
Give a very brief answer. 0.03. What is the difference between the highest and the second highest Emissions(in percent) of Georgia?
Provide a succinct answer. 4.13. What is the difference between the highest and the second highest Emissions(in percent) in Venezuela?
Make the answer very short. 2.28. What is the difference between the highest and the lowest Emissions(in percent) of Argentina?
Your answer should be very brief. 3.89. What is the difference between the highest and the lowest Emissions(in percent) of Brazil?
Give a very brief answer. 1.89. What is the difference between the highest and the lowest Emissions(in percent) of Georgia?
Offer a very short reply. 27.04. What is the difference between the highest and the lowest Emissions(in percent) in Venezuela?
Offer a terse response. 6.64. 